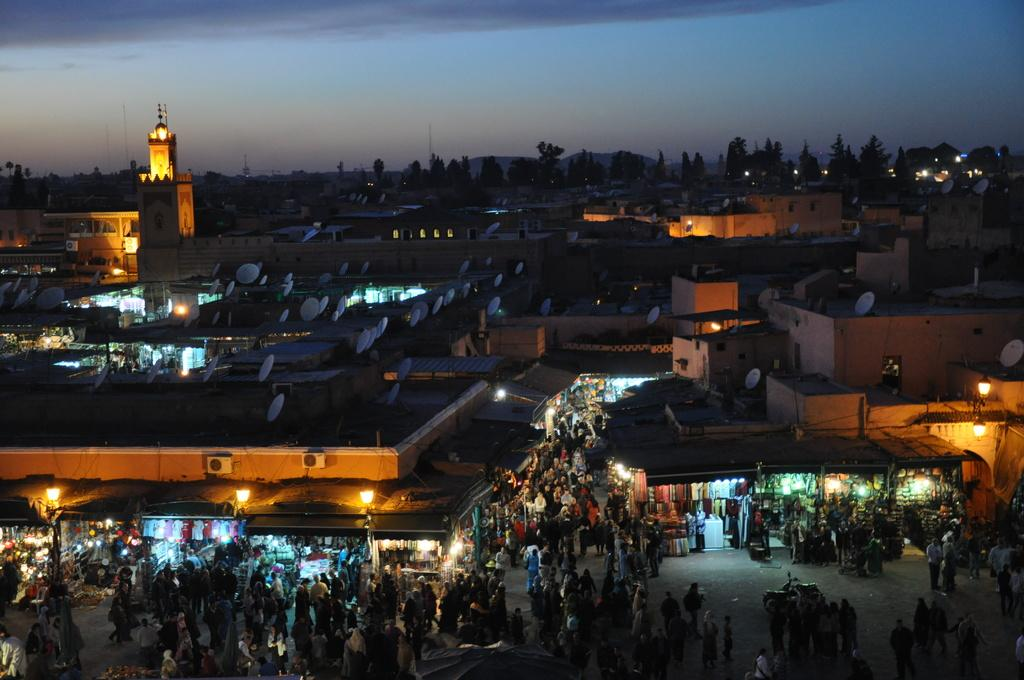Who or what can be seen in the image? There are people in the image. What type of structures are present in the image? There are stalls in the image. Are there any artificial light sources visible in the image? Yes, there are lights in the image. What type of residential buildings can be seen in the image? There are houses in the image. What type of communication devices are present in the image? There are dish antennas in the image. What natural elements can be seen in the background of the image? The background of the image includes trees. What part of the natural environment is visible in the background of the image? The sky is visible in the background of the image. Can you tell me how many grapes are hanging from the trees in the image? There are no grapes visible in the image; the trees are not mentioned as having any fruit. Is there a tiger walking through the stalls in the image? No, there is no tiger present in the image. 